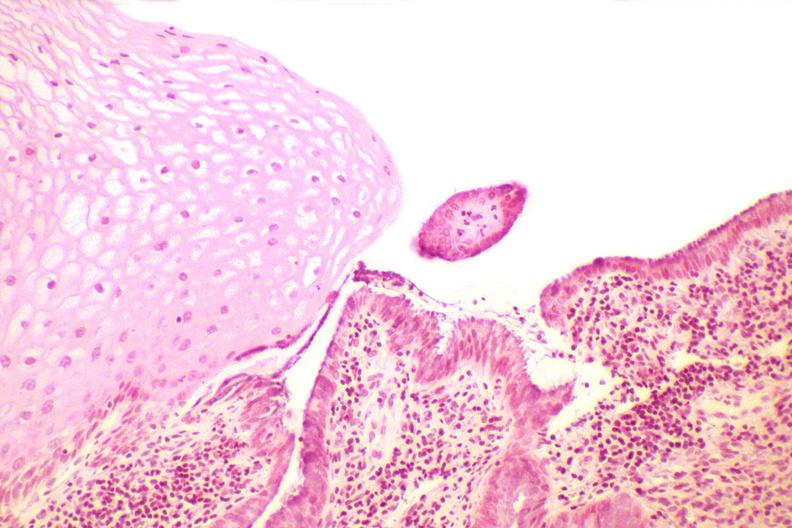s abdomen present?
Answer the question using a single word or phrase. No 